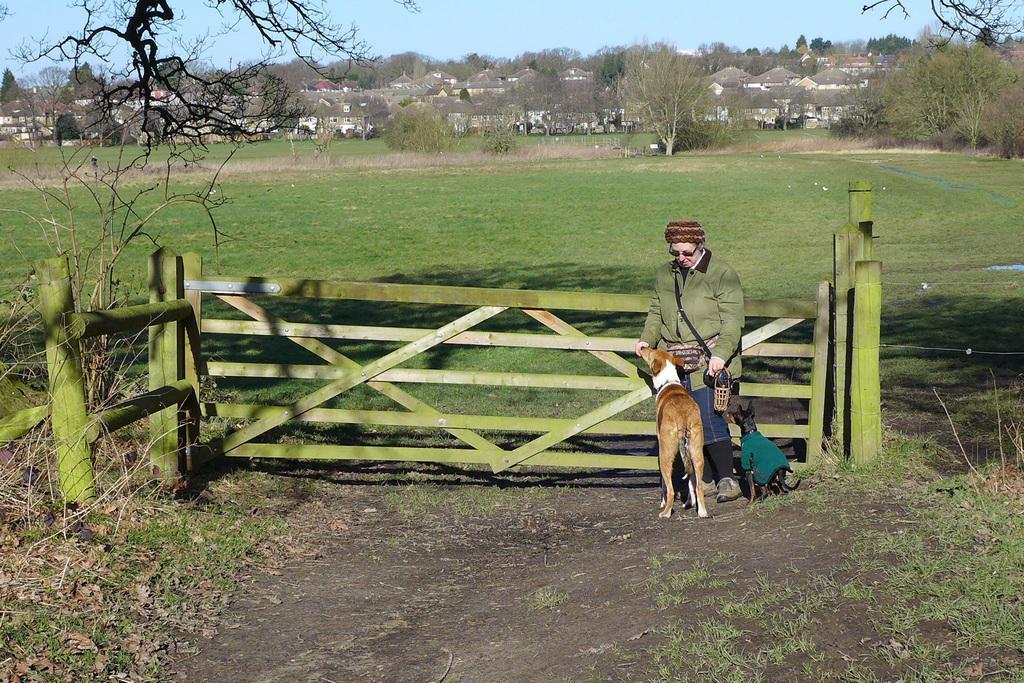Describe this image in one or two sentences. In this image I can see a person wearing green jacket, blue jeans is standing and holding few objects in his hand. I can see a dog which is brown and white in color and another dog which is black in color are standing on the ground. I can see the wooden fencing, some grass and few trees. In the background I can see few buildings, few trees and the sky. 